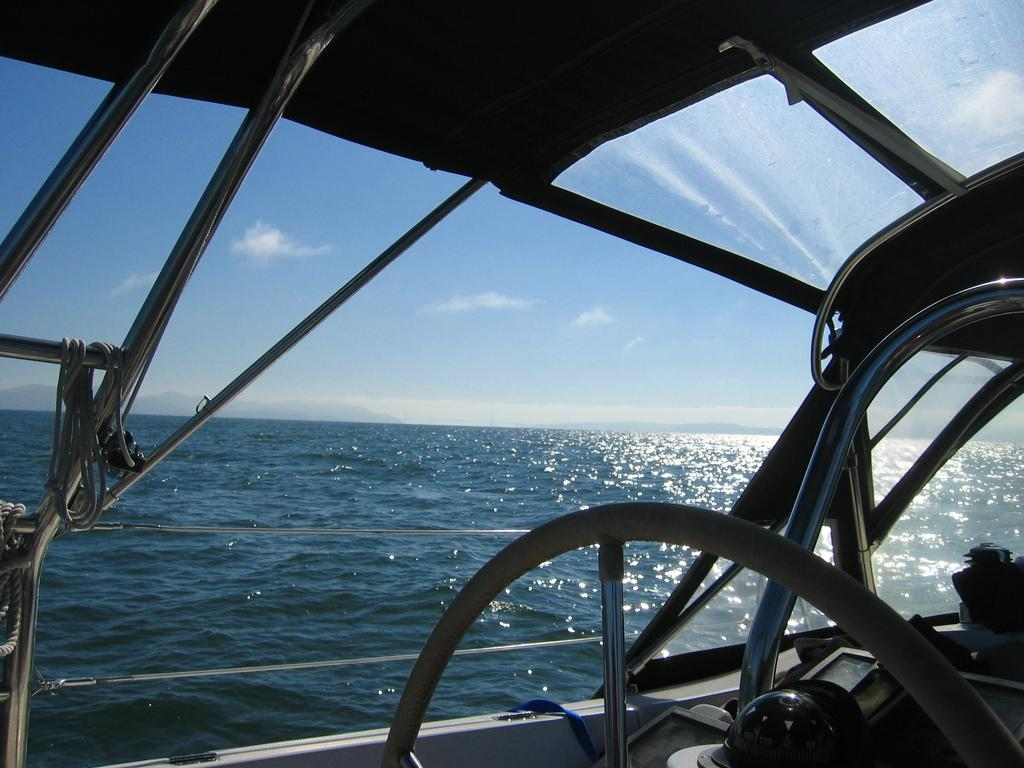What is the main subject of the image? The main subject of the image is a ship. What can be seen in the background of the image? There is water and the sky visible in the image. What type of instrument is being played during the feast in the image? There is no feast or instrument present in the image; it features a ship on water with the sky in the background. 